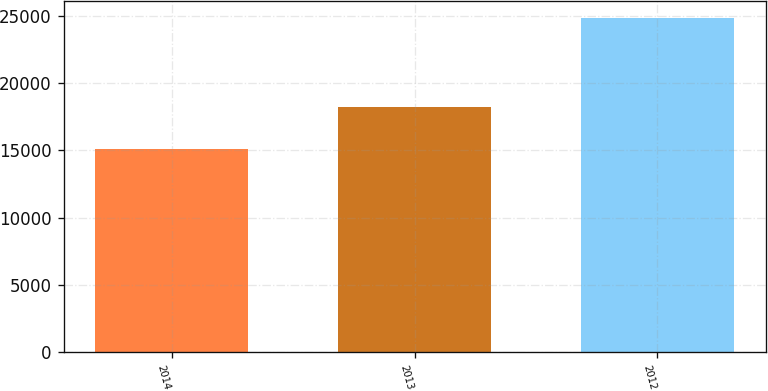<chart> <loc_0><loc_0><loc_500><loc_500><bar_chart><fcel>2014<fcel>2013<fcel>2012<nl><fcel>15125<fcel>18188<fcel>24823<nl></chart> 